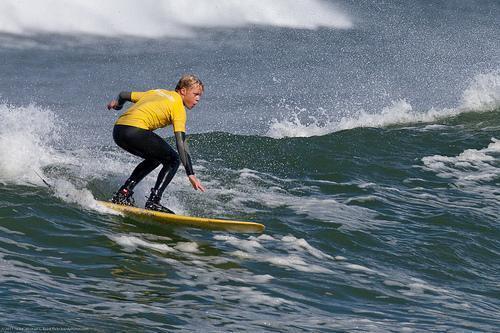How many surfers are there?
Give a very brief answer. 1. 